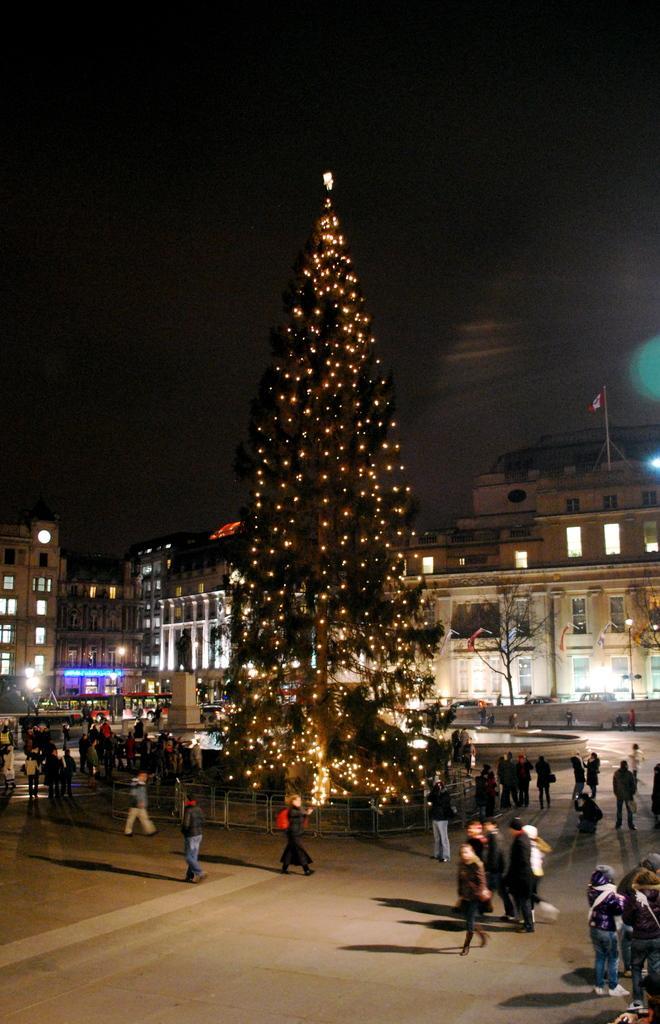In one or two sentences, can you explain what this image depicts? This picture is clicked outside the city. At the bottom of the picture, we see people are walking on the road. In the middle of the picture, we see a tree which is decorated with the lights. There are street lights, buildings and trees in the background. At the top of the picture, we see the sky. This picture is clicked in the dark. 